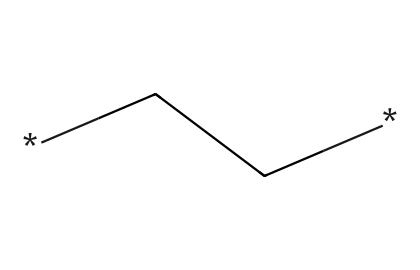how many carbon atoms are present in the structure? The SMILES notation "CC" represents two carbon atoms connected by a single bond. Each "C" in the SMILES indicates a carbon atom in the compound.
Answer: 2 what is the degree of unsaturation in this compound? The structure represented by "CC" is fully saturated, as it contains only single bonds between carbon atoms. Therefore, it has no degree of unsaturation.
Answer: 0 does this chemical belong to saturated or unsaturated hydrocarbons? The presence of only single bonds in the structure indicates that this compound is saturated. Saturated hydrocarbons have the maximum number of hydrogen atoms attached to the carbon backbone without double or triple bonds.
Answer: saturated what is the main use of polyethylene in handball equipment? Polyethylene, due to its lightweight and flexible properties, is commonly used to manufacture protective gear and balls in handball for enhanced safety and performance.
Answer: protective gear how does the chemical structure of polyethylene contribute to its flexibility? The linear arrangement of carbon atoms and the lack of rigid bonds allow polyethylene chains to move and slide past one another, resulting in a flexible material suitable for various applications, including sports equipment.
Answer: flexibility what type of bonding is found in polyethylene? In polyethylene, the bonding between the carbon atoms is covalent, which involves the sharing of electron pairs between atoms, contributing to its stability and structure.
Answer: covalent what impact does the structure of polyethylene have on its weight? The simple linear structure with relatively low molecular weight due to only carbon and hydrogen atoms contributes to polyethylene's overall low density, making it lightweight and practical for handball equipment.
Answer: lightweight 